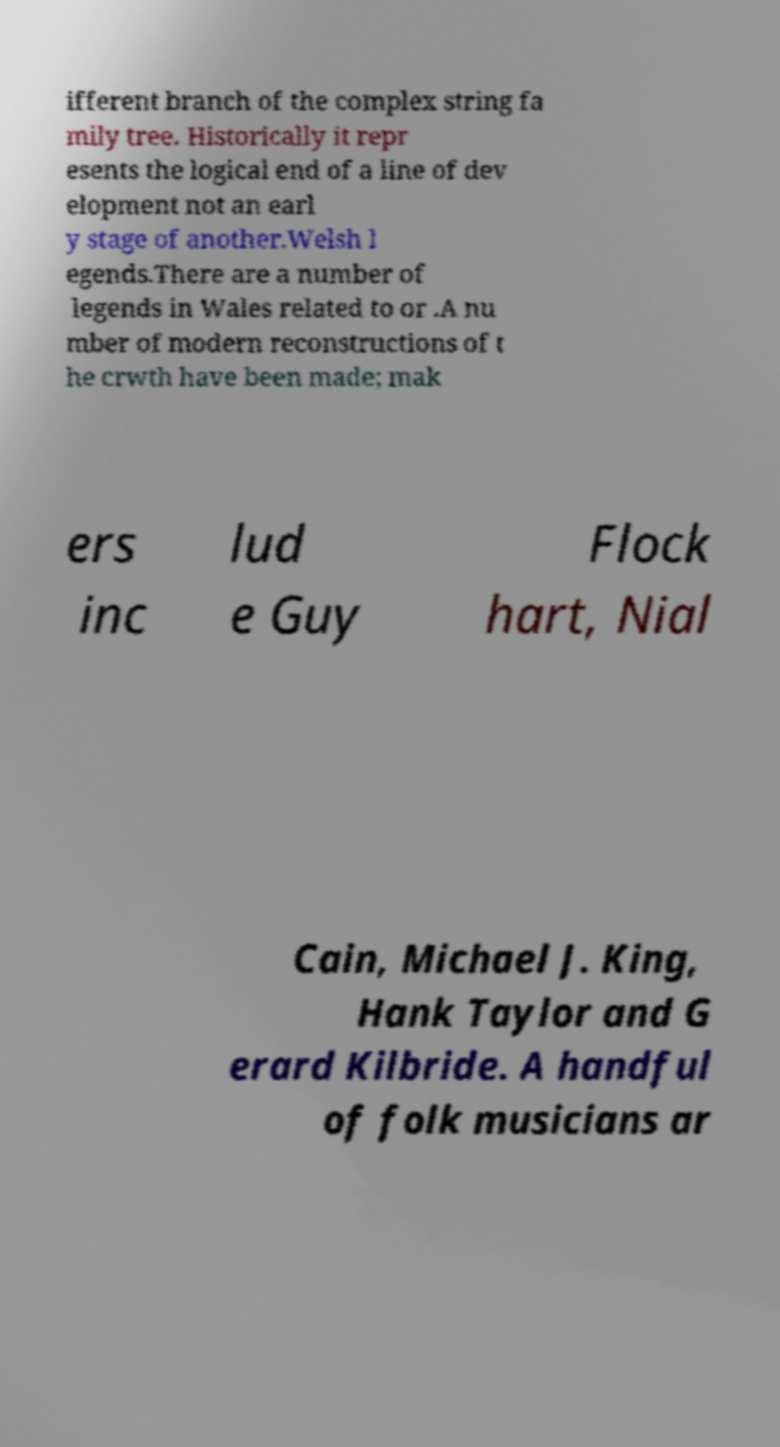For documentation purposes, I need the text within this image transcribed. Could you provide that? ifferent branch of the complex string fa mily tree. Historically it repr esents the logical end of a line of dev elopment not an earl y stage of another.Welsh l egends.There are a number of legends in Wales related to or .A nu mber of modern reconstructions of t he crwth have been made; mak ers inc lud e Guy Flock hart, Nial Cain, Michael J. King, Hank Taylor and G erard Kilbride. A handful of folk musicians ar 